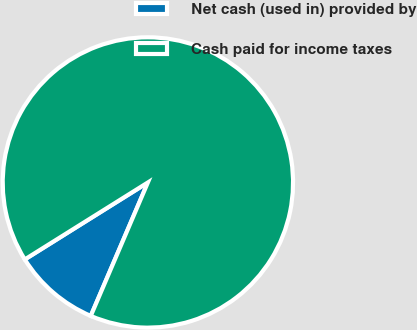Convert chart to OTSL. <chart><loc_0><loc_0><loc_500><loc_500><pie_chart><fcel>Net cash (used in) provided by<fcel>Cash paid for income taxes<nl><fcel>9.67%<fcel>90.33%<nl></chart> 